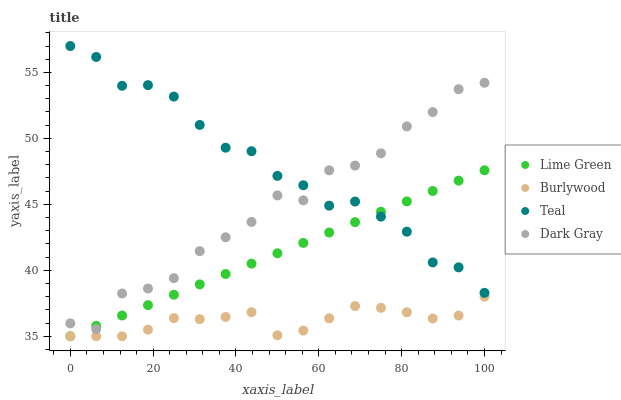Does Burlywood have the minimum area under the curve?
Answer yes or no. Yes. Does Teal have the maximum area under the curve?
Answer yes or no. Yes. Does Dark Gray have the minimum area under the curve?
Answer yes or no. No. Does Dark Gray have the maximum area under the curve?
Answer yes or no. No. Is Lime Green the smoothest?
Answer yes or no. Yes. Is Dark Gray the roughest?
Answer yes or no. Yes. Is Dark Gray the smoothest?
Answer yes or no. No. Is Lime Green the roughest?
Answer yes or no. No. Does Burlywood have the lowest value?
Answer yes or no. Yes. Does Dark Gray have the lowest value?
Answer yes or no. No. Does Teal have the highest value?
Answer yes or no. Yes. Does Dark Gray have the highest value?
Answer yes or no. No. Is Burlywood less than Dark Gray?
Answer yes or no. Yes. Is Dark Gray greater than Burlywood?
Answer yes or no. Yes. Does Lime Green intersect Dark Gray?
Answer yes or no. Yes. Is Lime Green less than Dark Gray?
Answer yes or no. No. Is Lime Green greater than Dark Gray?
Answer yes or no. No. Does Burlywood intersect Dark Gray?
Answer yes or no. No. 